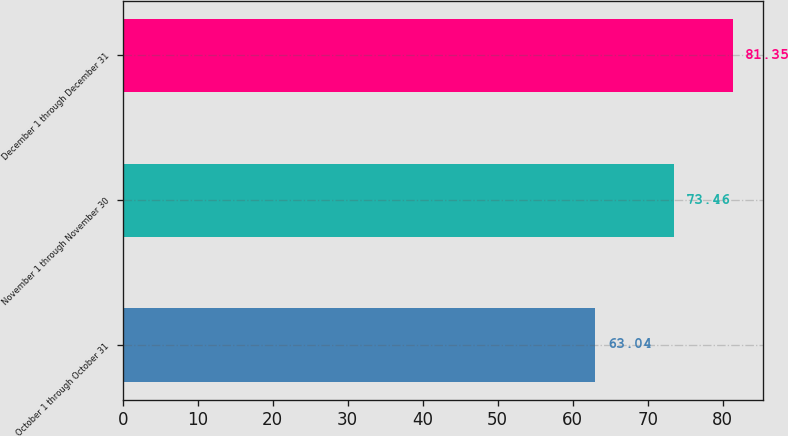Convert chart. <chart><loc_0><loc_0><loc_500><loc_500><bar_chart><fcel>October 1 through October 31<fcel>November 1 through November 30<fcel>December 1 through December 31<nl><fcel>63.04<fcel>73.46<fcel>81.35<nl></chart> 